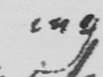What is written in this line of handwriting? ing 